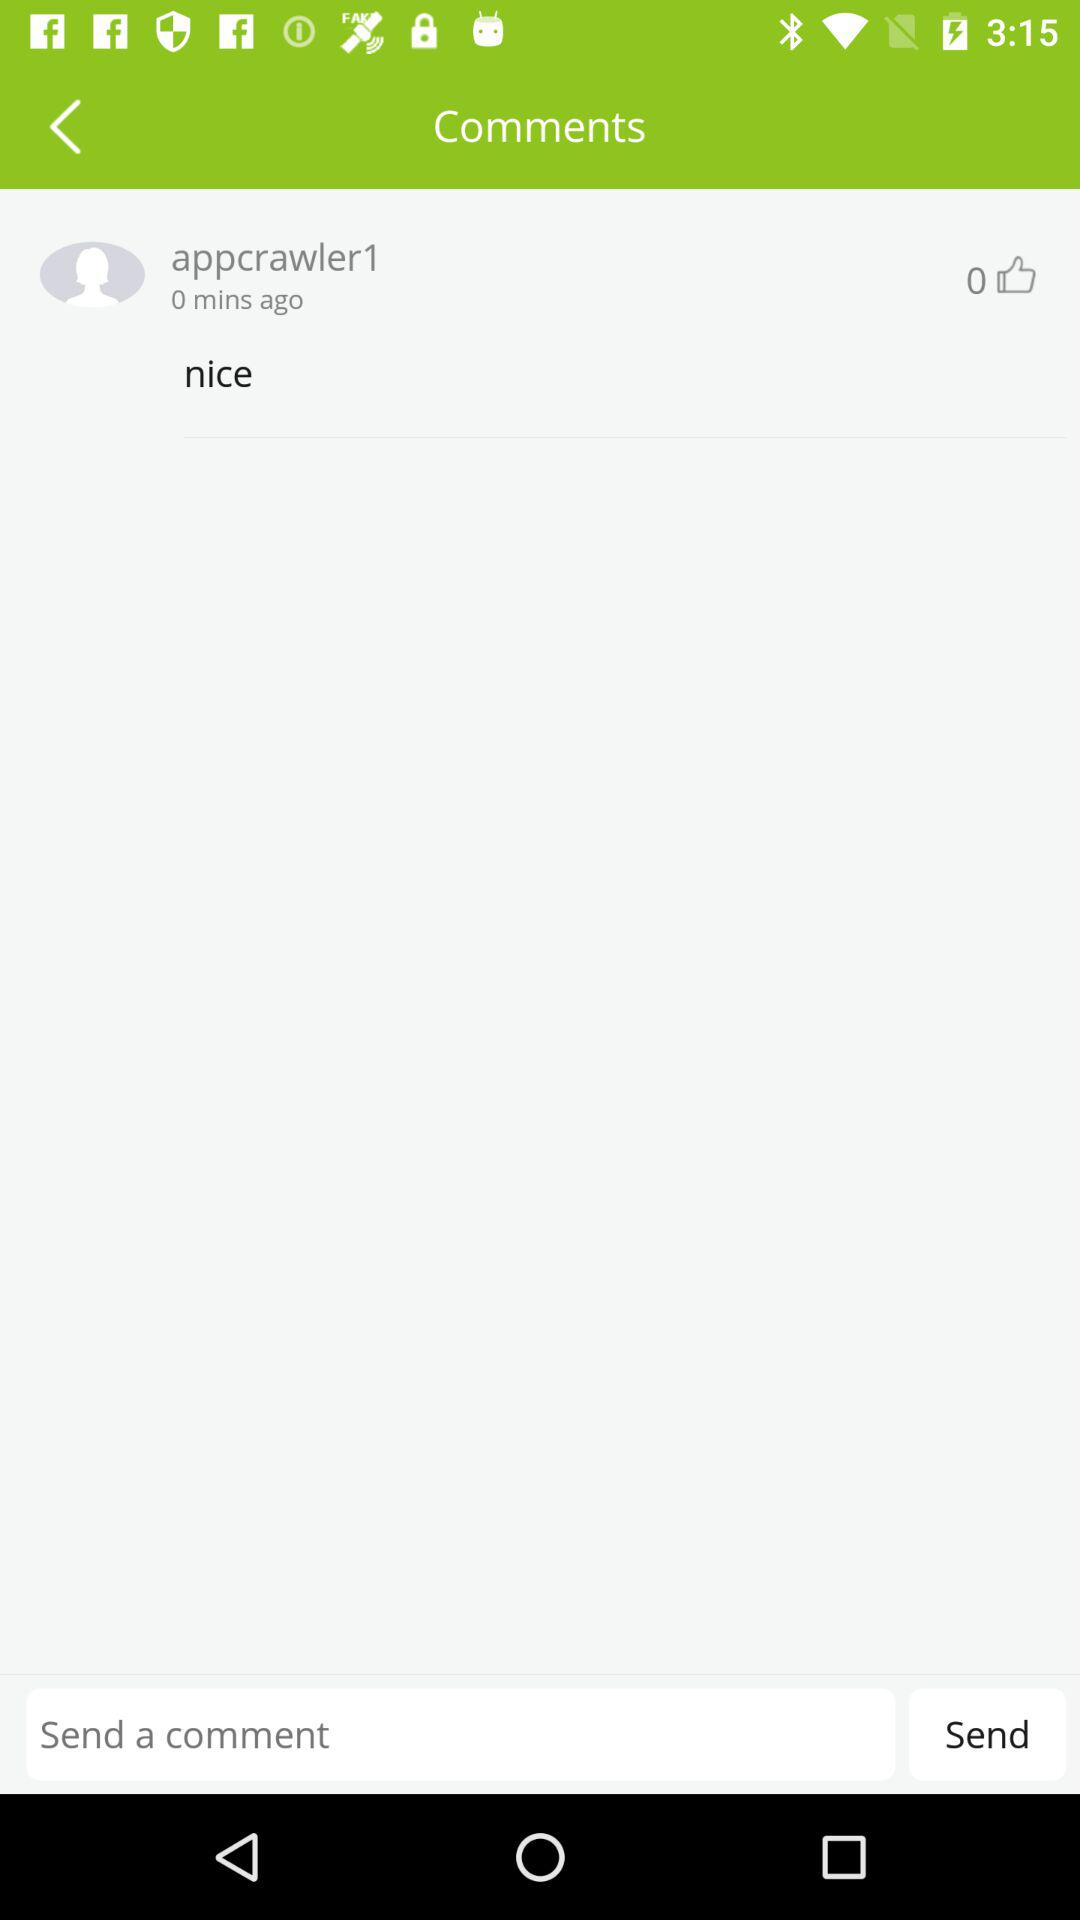What is the commenter's name? The commenter's name is "appcrawler1". 